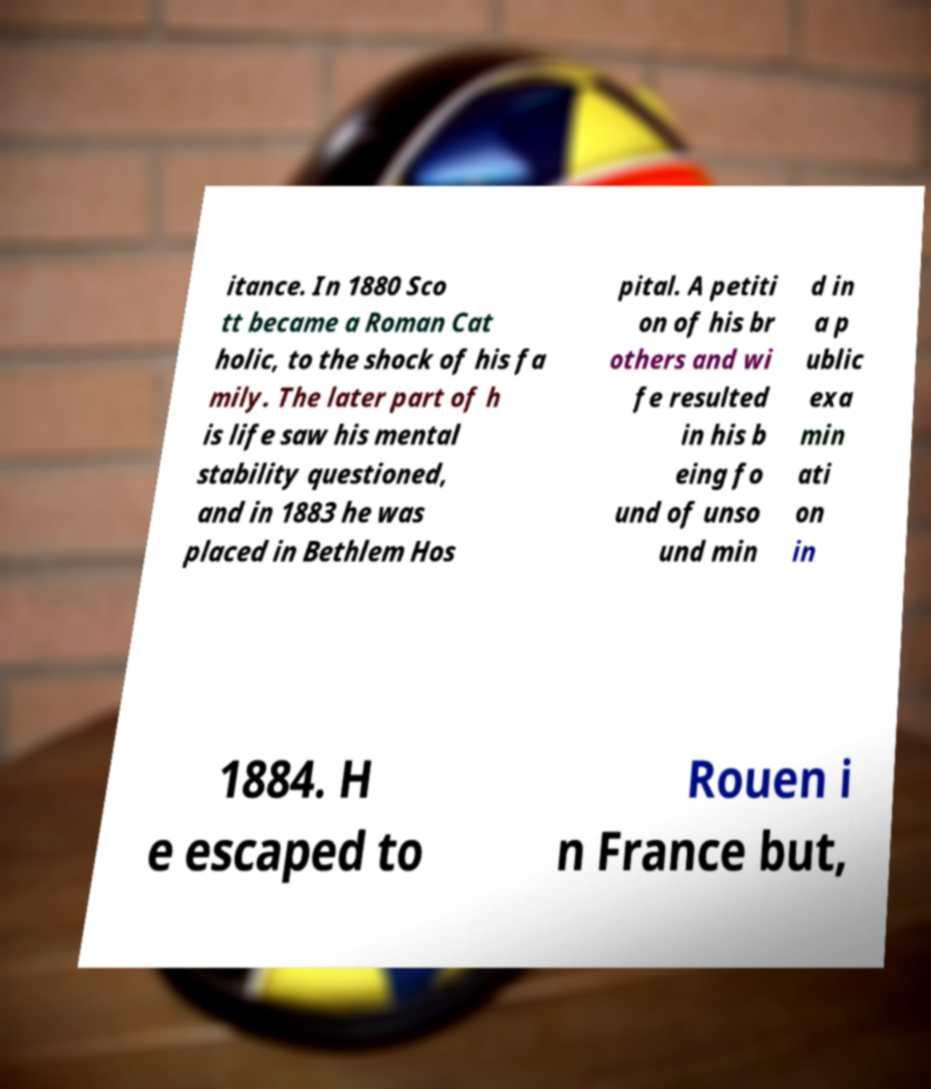Can you read and provide the text displayed in the image?This photo seems to have some interesting text. Can you extract and type it out for me? itance. In 1880 Sco tt became a Roman Cat holic, to the shock of his fa mily. The later part of h is life saw his mental stability questioned, and in 1883 he was placed in Bethlem Hos pital. A petiti on of his br others and wi fe resulted in his b eing fo und of unso und min d in a p ublic exa min ati on in 1884. H e escaped to Rouen i n France but, 